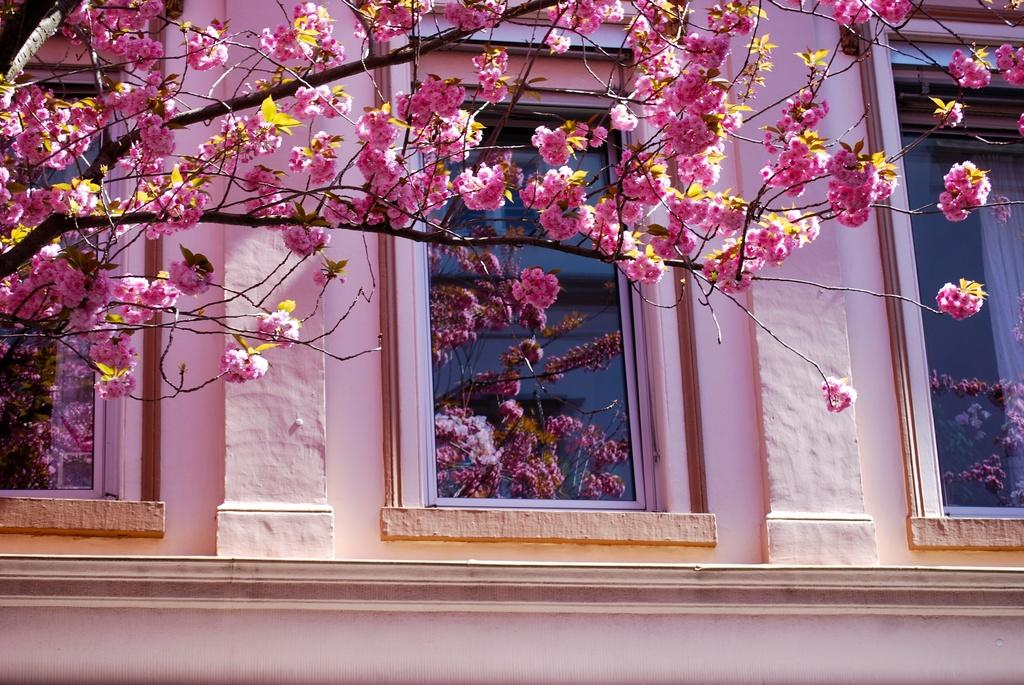What type of flowers are present in the image? There are blossoms in the image. What architectural feature can be seen in the image? There are windows visible in the image. To which structure do the windows belong? The windows belong to a building. What type of treatment is being administered to the blossoms in the image? There is no treatment being administered to the blossoms in the image; they are simply present. 